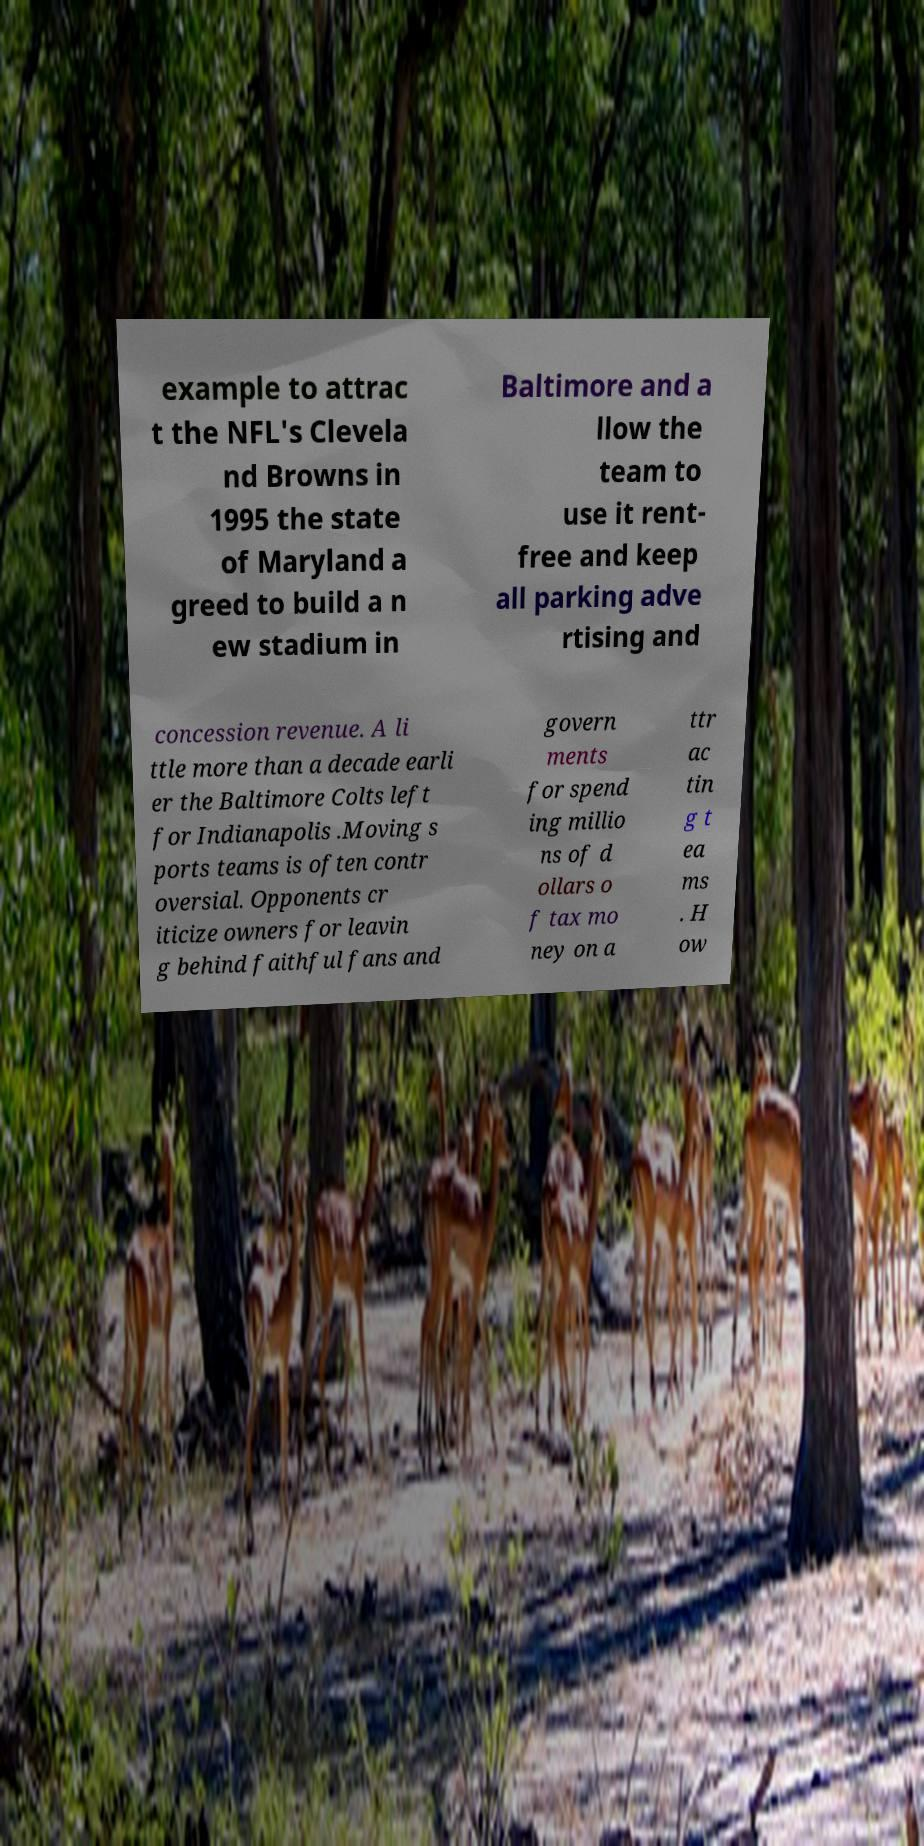What messages or text are displayed in this image? I need them in a readable, typed format. example to attrac t the NFL's Clevela nd Browns in 1995 the state of Maryland a greed to build a n ew stadium in Baltimore and a llow the team to use it rent- free and keep all parking adve rtising and concession revenue. A li ttle more than a decade earli er the Baltimore Colts left for Indianapolis .Moving s ports teams is often contr oversial. Opponents cr iticize owners for leavin g behind faithful fans and govern ments for spend ing millio ns of d ollars o f tax mo ney on a ttr ac tin g t ea ms . H ow 